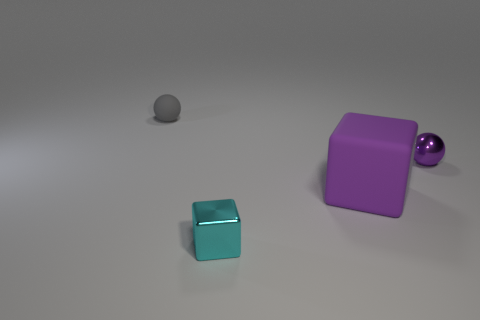How do the different materials of the objects interact with the light in the scene? The metallic object reflects light and has a visible highlight, while the matte surfaces of the other objects absorb more light, resulting in less reflection and more evenly diffused shadows, creating a balance of textures and lighting effects. Could you tell me if these objects share any common features? Although the objects differ in shape and potentially material, they share a unifying color palette, ranging from a lighter tone on the small sphere to deeper hues on the larger cube and reflective ball, creating a cohesive visual link between them. 